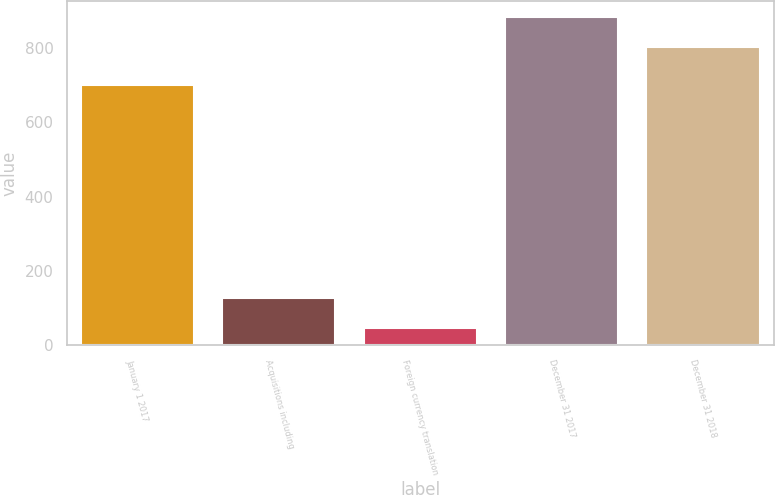Convert chart. <chart><loc_0><loc_0><loc_500><loc_500><bar_chart><fcel>January 1 2017<fcel>Acquisitions including<fcel>Foreign currency translation<fcel>December 31 2017<fcel>December 31 2018<nl><fcel>702<fcel>126.1<fcel>47<fcel>883.1<fcel>804<nl></chart> 